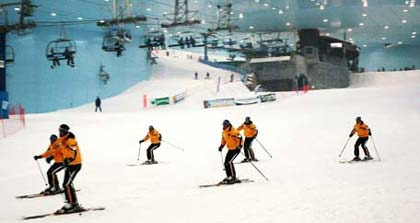Imagine this indoor skiing facility is hosting a special event. What could that event be and how would it be set up? Imagine this indoor skiing facility is hosting a Winter Wonderland Festival. The event could include a variety of activities like skiing competitions, snowboarding demonstrations, and fun activities like snowball fights, igloo building, and winter-themed games for kids. The facility would be decorated with fairy lights, ice sculptures, and festive banners. There could be a dedicated area with stalls selling hot chocolate, snacks, and winter accessories, along with a stage for live performances and music. 